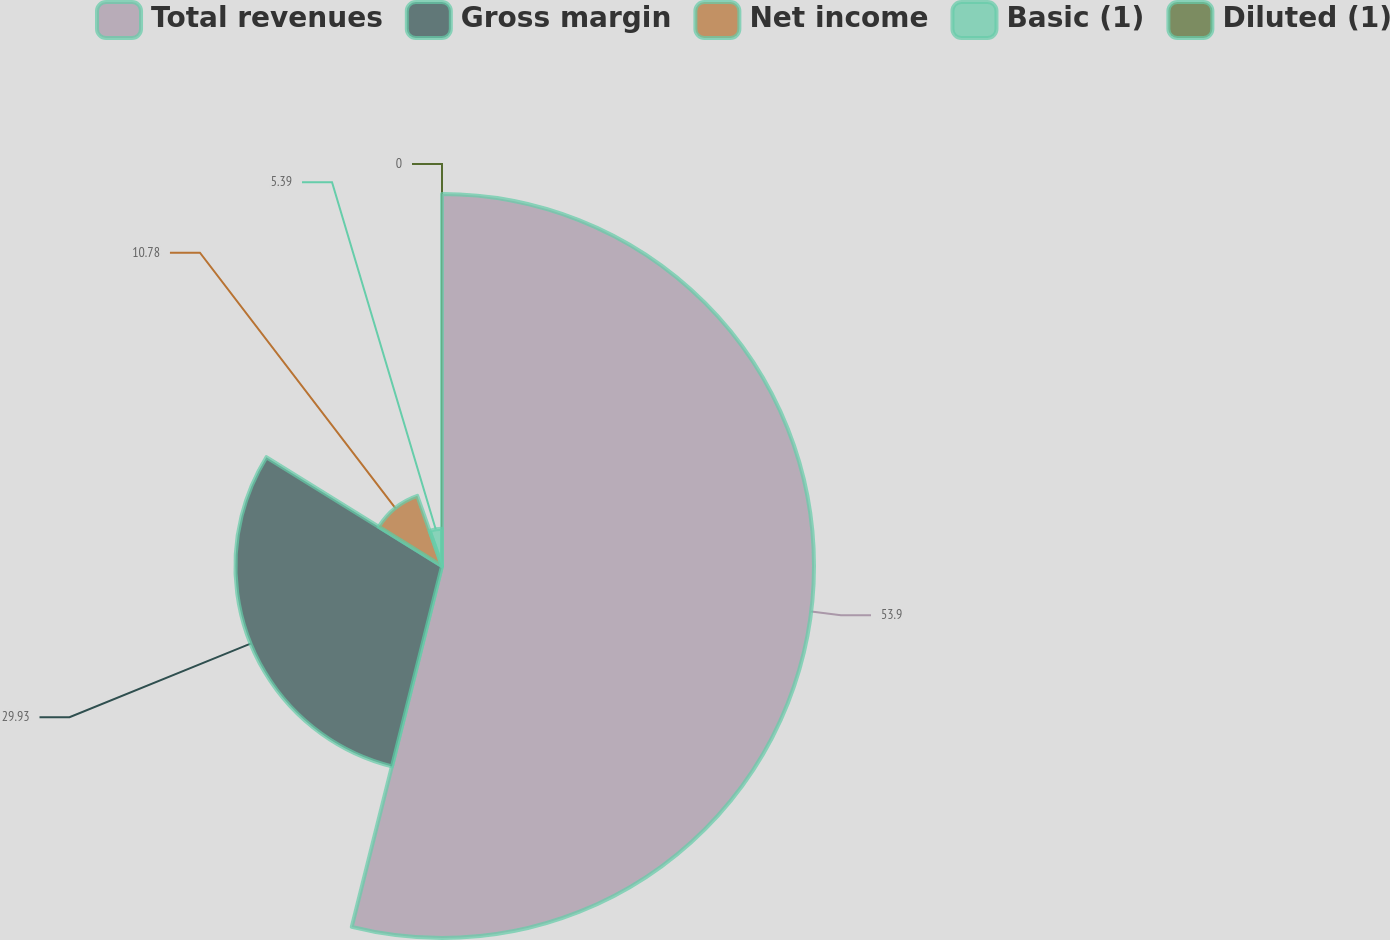Convert chart to OTSL. <chart><loc_0><loc_0><loc_500><loc_500><pie_chart><fcel>Total revenues<fcel>Gross margin<fcel>Net income<fcel>Basic (1)<fcel>Diluted (1)<nl><fcel>53.9%<fcel>29.93%<fcel>10.78%<fcel>5.39%<fcel>0.0%<nl></chart> 